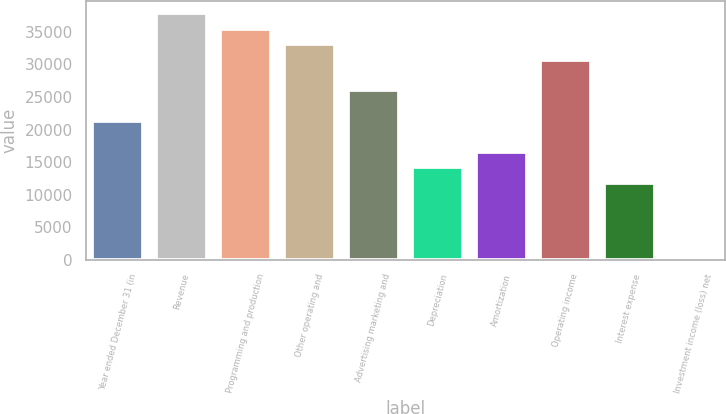Convert chart to OTSL. <chart><loc_0><loc_0><loc_500><loc_500><bar_chart><fcel>Year ended December 31 (in<fcel>Revenue<fcel>Programming and production<fcel>Other operating and<fcel>Advertising marketing and<fcel>Depreciation<fcel>Amortization<fcel>Operating income<fcel>Interest expense<fcel>Investment income (loss) net<nl><fcel>21286.7<fcel>37829.8<fcel>35466.5<fcel>33103.2<fcel>26013.3<fcel>14196.8<fcel>16560.1<fcel>30739.9<fcel>11833.5<fcel>17<nl></chart> 